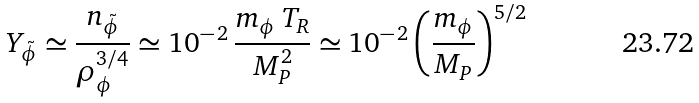Convert formula to latex. <formula><loc_0><loc_0><loc_500><loc_500>Y _ { \tilde { \phi } } \simeq \frac { n _ { \tilde { \phi } } } { \rho _ { \phi } ^ { 3 / 4 } } \simeq 1 0 ^ { - \, 2 } \, \frac { m _ { \phi } \, T _ { R } } { M _ { P } ^ { 2 } } \simeq 1 0 ^ { - \, 2 } \left ( \frac { m _ { \phi } } { M _ { P } } \right ) ^ { 5 / 2 }</formula> 